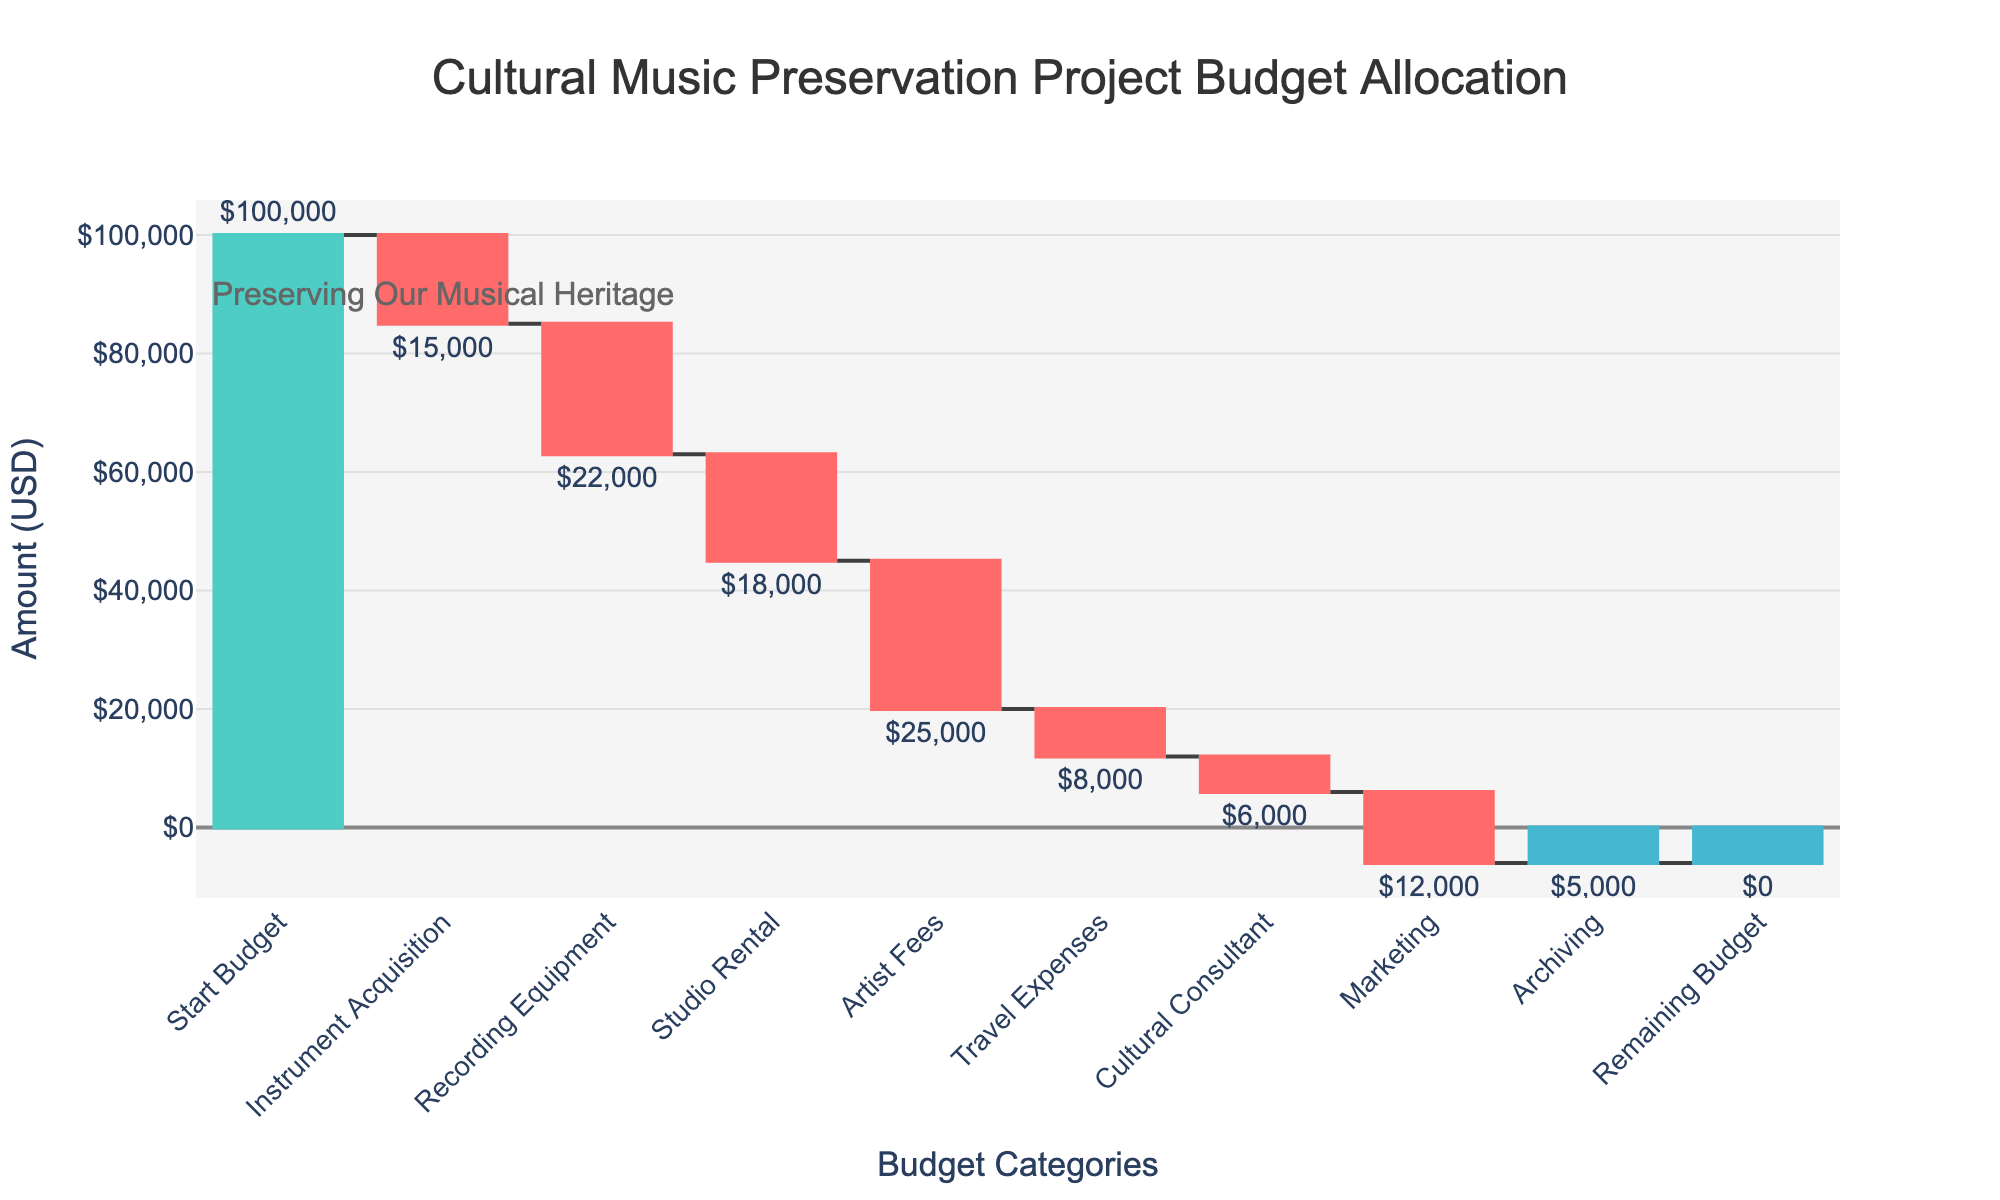How much is the start budget? The start budget is clearly labeled as "Start Budget" at the top of the chart. By examining the chart, we see that it is $100,000.
Answer: $100,000 What is the title of the chart? The title of the chart is displayed at the top and reads "Cultural Music Preservation Project Budget Allocation".
Answer: Cultural Music Preservation Project Budget Allocation Which expense category has the highest amount? By comparing the heights of the bars, we can see that "Artist Fees" has the largest expenditure of $25,000.
Answer: Artist Fees What is the total amount spent on Instrument Acquisition and Recording Equipment? The amount for "Instrument Acquisition" is $15,000 and for "Recording Equipment" is $22,000. Adding these amounts gives $15,000 + $22,000 = $37,000.
Answer: $37,000 How much money is left after Studio Rental? By locating the "Studio Rental" bar and summing the expenses up to this point ($15,000 + $22,000 + $18,000 = $55,000), and subtracting from the start budget ($100,000 - $55,000 = $45,000), we find $45,000 remains after Studio Rental.
Answer: $45,000 How much is spent on Marketing compared to Travel Expenses? The "Marketing" bar is smaller than the "Travel Expenses" bar, representing an expenditure of $12,000 versus $8,000. Therefore, marketing expenses are higher than travel expenses by $12,000 - $8,000 = $4,000.
Answer: $4,000 more Which categories contributed to the remaining budget of zero? All categories contribute since there is a cumulative effect. Summing the expenses: $15,000 + $22,000 + $18,000 + $25,000 + $8,000 + $6,000 + $12,000 + $5,000 = $111,000. Subtracting from the start budget ($100,000 - $111,000 = -$11,000) indicates discrepancy or additional unlisted adjustments leading to the final budget remaining at zero.
Answer: All categories What is the mean expense across all categories except the start and remaining budget? First, sum the amounts spent ($15,000 + $22,000 + $18,000 + $25,000 + $8,000 + $6,000 + $12,000 + $5,000 = $111,000). There are 8 categories. The mean is $111,000 / 8 = $13,875.
Answer: $13,875 Is the expenditure on Cultural Consultant higher or lower than Archiving? The "Cultural Consultant" expenditure is $6,000, while "Archiving" is $5,000. Therefore, the expenditure on the Cultural Consultant is higher than Archiving by $6,000 - $5,000 = $1,000.
Answer: Higher by $1,000 What is the decrease in the budget after the Artist Fees are considered? The budget before Artist Fees is the initial start budget minus the expenses up to Artist Fees ($100,000 - $15,000 - $22,000 - $18,000 = $45,000). After Artist Fees, it is $45,000 - $25,000 = $20,000. Thus, the decrease is $45,000 - $20,000 = $25,000.
Answer: $25,000 